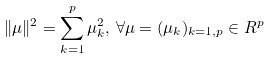Convert formula to latex. <formula><loc_0><loc_0><loc_500><loc_500>\| \mu \| ^ { 2 } = \sum _ { k = 1 } ^ { p } \mu _ { k } ^ { 2 } , \, \forall \mu = ( \mu _ { k } ) _ { k = 1 , p } \in R ^ { p }</formula> 